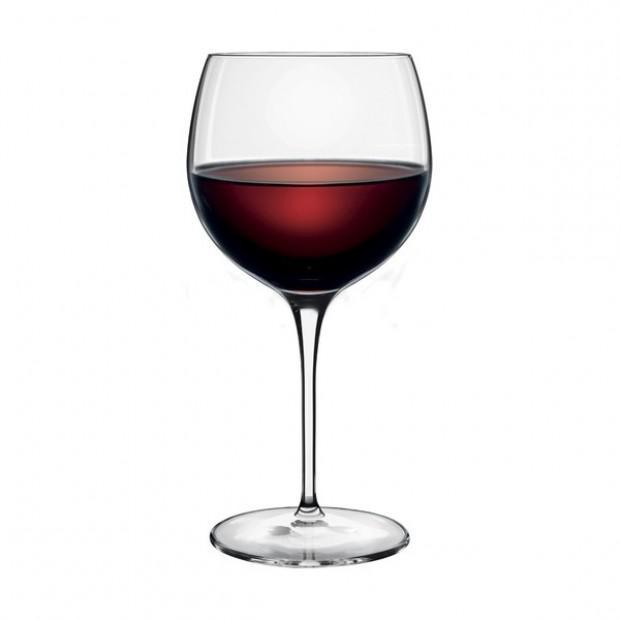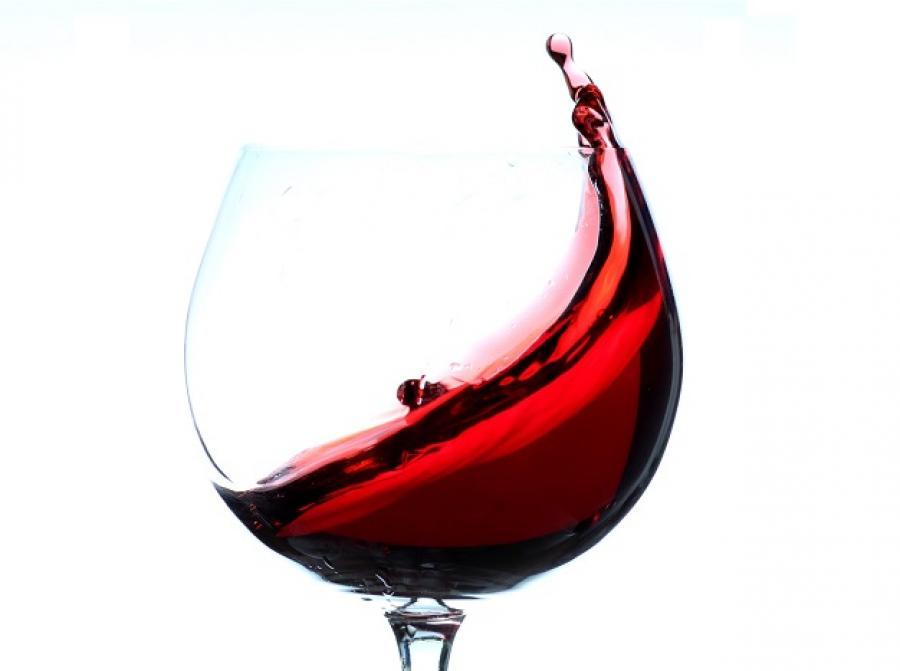The first image is the image on the left, the second image is the image on the right. Examine the images to the left and right. Is the description "There is at least two wine glasses in the right image." accurate? Answer yes or no. No. 